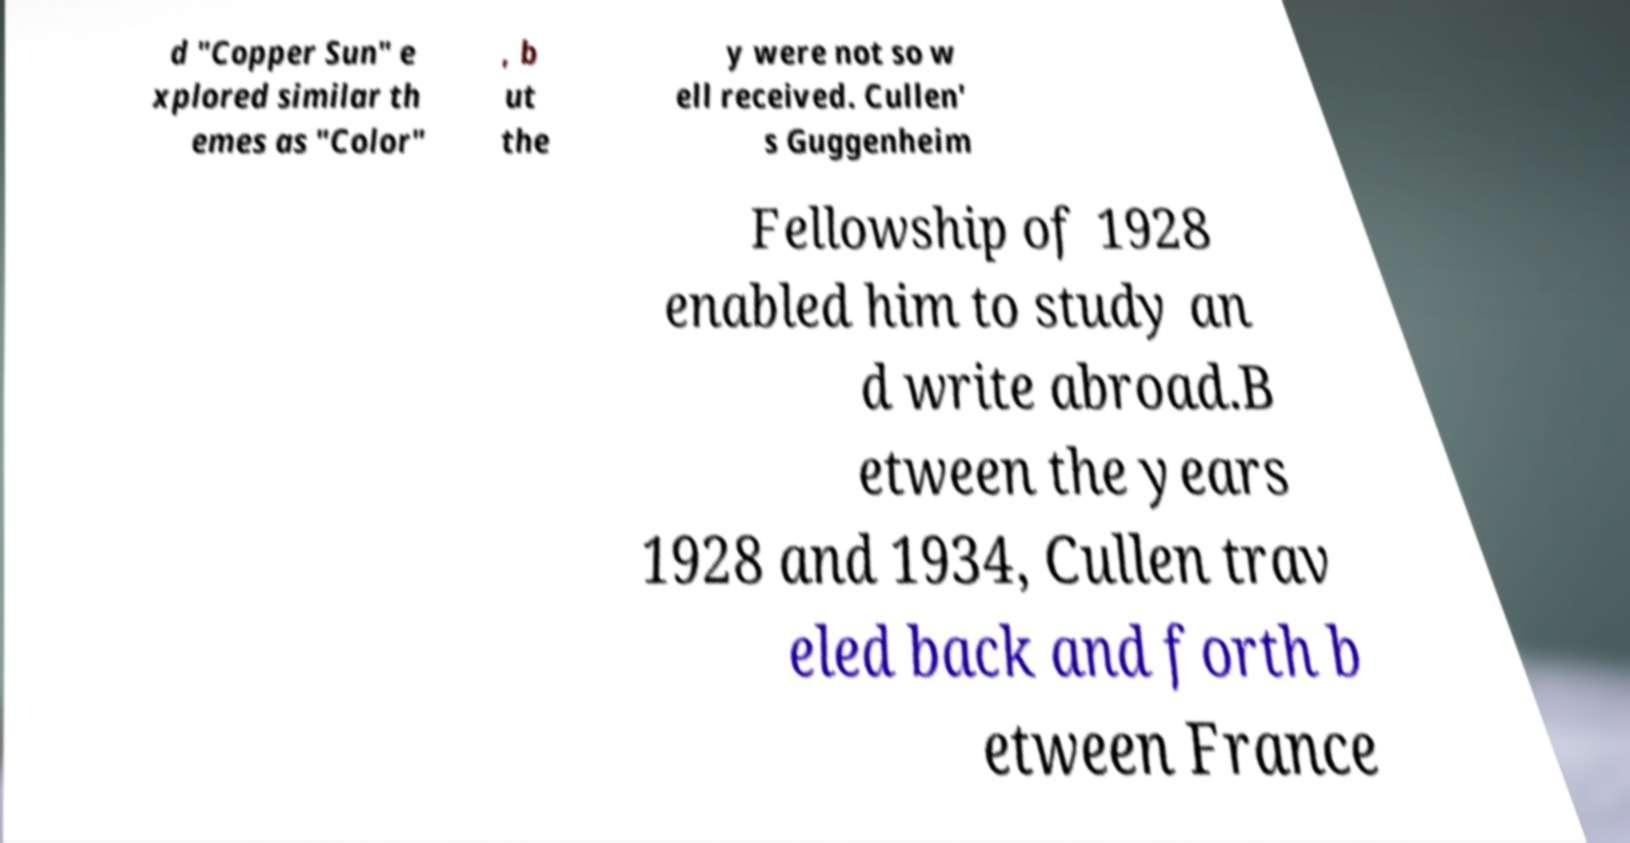For documentation purposes, I need the text within this image transcribed. Could you provide that? d "Copper Sun" e xplored similar th emes as "Color" , b ut the y were not so w ell received. Cullen' s Guggenheim Fellowship of 1928 enabled him to study an d write abroad.B etween the years 1928 and 1934, Cullen trav eled back and forth b etween France 